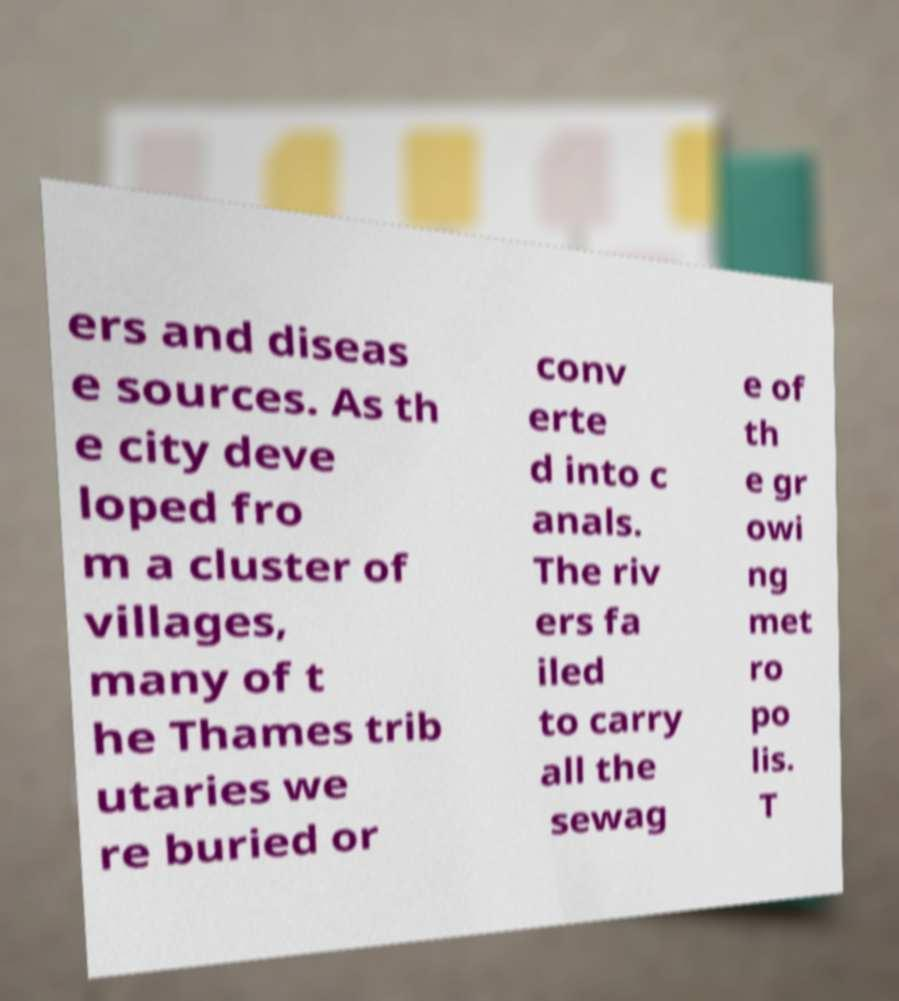There's text embedded in this image that I need extracted. Can you transcribe it verbatim? ers and diseas e sources. As th e city deve loped fro m a cluster of villages, many of t he Thames trib utaries we re buried or conv erte d into c anals. The riv ers fa iled to carry all the sewag e of th e gr owi ng met ro po lis. T 